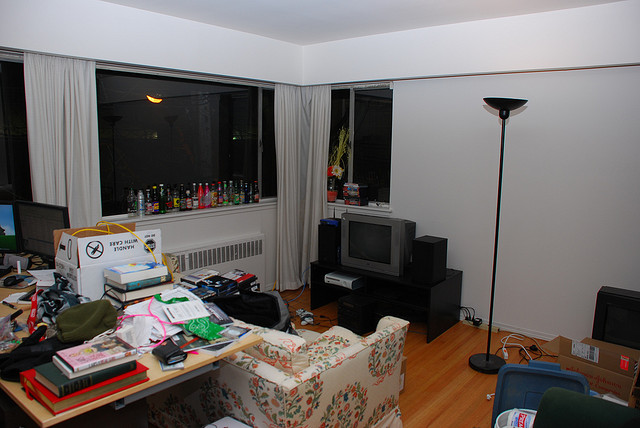<image>What type of house is this? I am not sure what type of house this is. It could be an apartment or a frat house. What material is the coach made out of? I am not sure what material the coach is made out of. It could be polyester, cotton, linen, or cloth. What type of house is this? I am not sure what type of house it is. It can be seen as an apartment or a frat house. What material is the coach made out of? I don't know what material the coach is made out of. It can be polyester, cotton, cloth, linen, or fabric. 